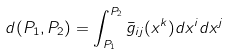Convert formula to latex. <formula><loc_0><loc_0><loc_500><loc_500>d ( P _ { 1 } , P _ { 2 } ) = \int _ { P _ { 1 } } ^ { P _ { 2 } } \bar { g } _ { i j } ( x ^ { k } ) d x ^ { i } d x ^ { j }</formula> 